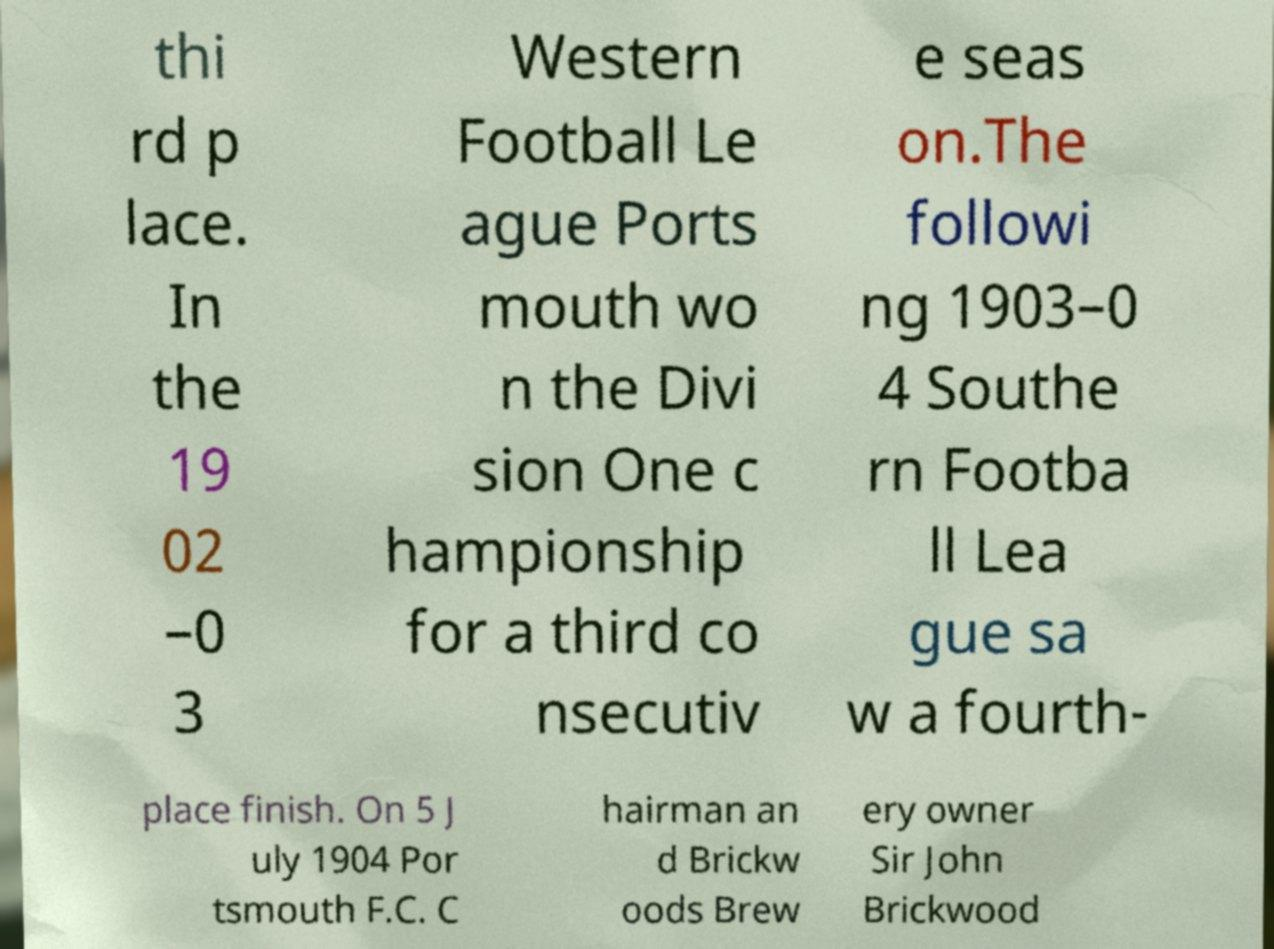I need the written content from this picture converted into text. Can you do that? thi rd p lace. In the 19 02 –0 3 Western Football Le ague Ports mouth wo n the Divi sion One c hampionship for a third co nsecutiv e seas on.The followi ng 1903–0 4 Southe rn Footba ll Lea gue sa w a fourth- place finish. On 5 J uly 1904 Por tsmouth F.C. C hairman an d Brickw oods Brew ery owner Sir John Brickwood 